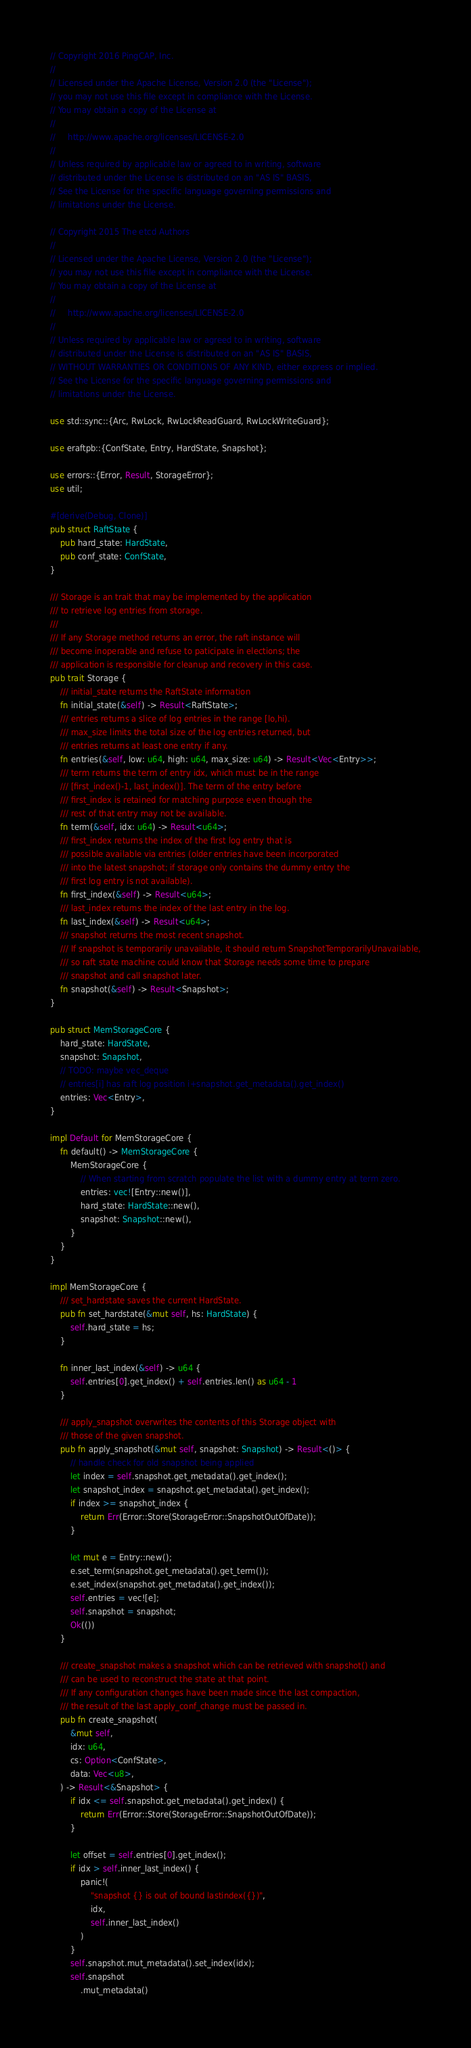<code> <loc_0><loc_0><loc_500><loc_500><_Rust_>// Copyright 2016 PingCAP, Inc.
//
// Licensed under the Apache License, Version 2.0 (the "License");
// you may not use this file except in compliance with the License.
// You may obtain a copy of the License at
//
//     http://www.apache.org/licenses/LICENSE-2.0
//
// Unless required by applicable law or agreed to in writing, software
// distributed under the License is distributed on an "AS IS" BASIS,
// See the License for the specific language governing permissions and
// limitations under the License.

// Copyright 2015 The etcd Authors
//
// Licensed under the Apache License, Version 2.0 (the "License");
// you may not use this file except in compliance with the License.
// You may obtain a copy of the License at
//
//     http://www.apache.org/licenses/LICENSE-2.0
//
// Unless required by applicable law or agreed to in writing, software
// distributed under the License is distributed on an "AS IS" BASIS,
// WITHOUT WARRANTIES OR CONDITIONS OF ANY KIND, either express or implied.
// See the License for the specific language governing permissions and
// limitations under the License.

use std::sync::{Arc, RwLock, RwLockReadGuard, RwLockWriteGuard};

use eraftpb::{ConfState, Entry, HardState, Snapshot};

use errors::{Error, Result, StorageError};
use util;

#[derive(Debug, Clone)]
pub struct RaftState {
    pub hard_state: HardState,
    pub conf_state: ConfState,
}

/// Storage is an trait that may be implemented by the application
/// to retrieve log entries from storage.
///
/// If any Storage method returns an error, the raft instance will
/// become inoperable and refuse to paticipate in elections; the
/// application is responsible for cleanup and recovery in this case.
pub trait Storage {
    /// initial_state returns the RaftState information
    fn initial_state(&self) -> Result<RaftState>;
    /// entries returns a slice of log entries in the range [lo,hi).
    /// max_size limits the total size of the log entries returned, but
    /// entries returns at least one entry if any.
    fn entries(&self, low: u64, high: u64, max_size: u64) -> Result<Vec<Entry>>;
    /// term returns the term of entry idx, which must be in the range
    /// [first_index()-1, last_index()]. The term of the entry before
    /// first_index is retained for matching purpose even though the
    /// rest of that entry may not be available.
    fn term(&self, idx: u64) -> Result<u64>;
    /// first_index returns the index of the first log entry that is
    /// possible available via entries (older entries have been incorporated
    /// into the latest snapshot; if storage only contains the dummy entry the
    /// first log entry is not available).
    fn first_index(&self) -> Result<u64>;
    /// last_index returns the index of the last entry in the log.
    fn last_index(&self) -> Result<u64>;
    /// snapshot returns the most recent snapshot.
    /// If snapshot is temporarily unavailable, it should return SnapshotTemporarilyUnavailable,
    /// so raft state machine could know that Storage needs some time to prepare
    /// snapshot and call snapshot later.
    fn snapshot(&self) -> Result<Snapshot>;
}

pub struct MemStorageCore {
    hard_state: HardState,
    snapshot: Snapshot,
    // TODO: maybe vec_deque
    // entries[i] has raft log position i+snapshot.get_metadata().get_index()
    entries: Vec<Entry>,
}

impl Default for MemStorageCore {
    fn default() -> MemStorageCore {
        MemStorageCore {
            // When starting from scratch populate the list with a dummy entry at term zero.
            entries: vec![Entry::new()],
            hard_state: HardState::new(),
            snapshot: Snapshot::new(),
        }
    }
}

impl MemStorageCore {
    /// set_hardstate saves the current HardState.
    pub fn set_hardstate(&mut self, hs: HardState) {
        self.hard_state = hs;
    }

    fn inner_last_index(&self) -> u64 {
        self.entries[0].get_index() + self.entries.len() as u64 - 1
    }

    /// apply_snapshot overwrites the contents of this Storage object with
    /// those of the given snapshot.
    pub fn apply_snapshot(&mut self, snapshot: Snapshot) -> Result<()> {
        // handle check for old snapshot being applied
        let index = self.snapshot.get_metadata().get_index();
        let snapshot_index = snapshot.get_metadata().get_index();
        if index >= snapshot_index {
            return Err(Error::Store(StorageError::SnapshotOutOfDate));
        }

        let mut e = Entry::new();
        e.set_term(snapshot.get_metadata().get_term());
        e.set_index(snapshot.get_metadata().get_index());
        self.entries = vec![e];
        self.snapshot = snapshot;
        Ok(())
    }

    /// create_snapshot makes a snapshot which can be retrieved with snapshot() and
    /// can be used to reconstruct the state at that point.
    /// If any configuration changes have been made since the last compaction,
    /// the result of the last apply_conf_change must be passed in.
    pub fn create_snapshot(
        &mut self,
        idx: u64,
        cs: Option<ConfState>,
        data: Vec<u8>,
    ) -> Result<&Snapshot> {
        if idx <= self.snapshot.get_metadata().get_index() {
            return Err(Error::Store(StorageError::SnapshotOutOfDate));
        }

        let offset = self.entries[0].get_index();
        if idx > self.inner_last_index() {
            panic!(
                "snapshot {} is out of bound lastindex({})",
                idx,
                self.inner_last_index()
            )
        }
        self.snapshot.mut_metadata().set_index(idx);
        self.snapshot
            .mut_metadata()</code> 